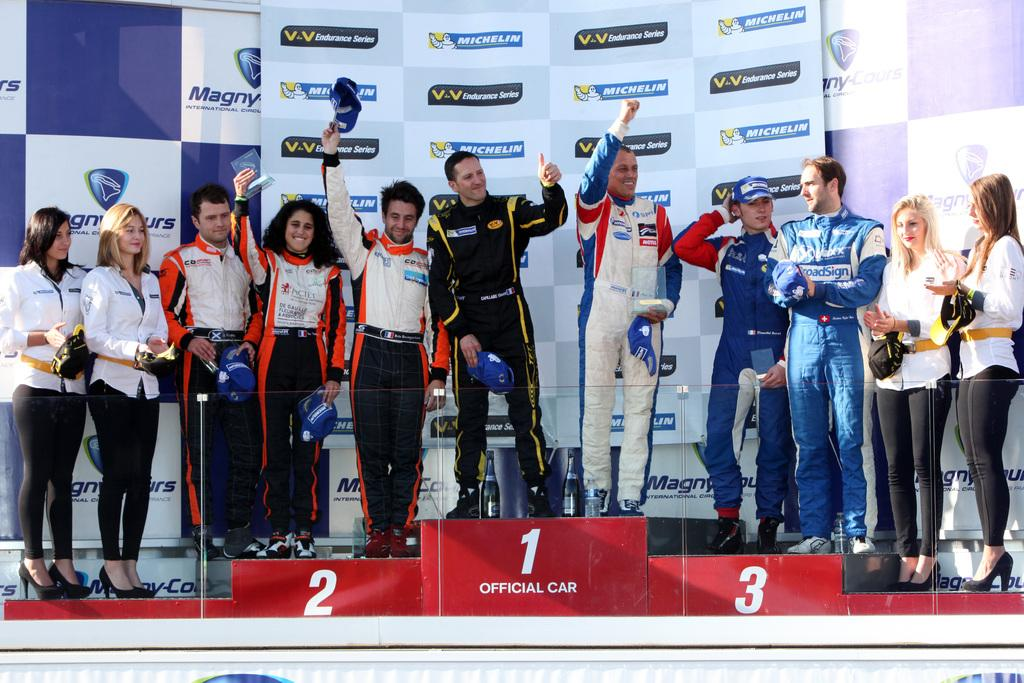<image>
Present a compact description of the photo's key features. A race car driver celebrates his victory on the podium with number 1 below it. 